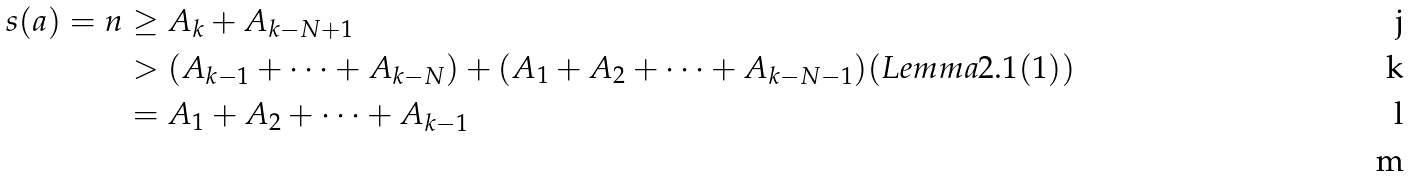Convert formula to latex. <formula><loc_0><loc_0><loc_500><loc_500>s ( a ) = n & \geq A _ { k } + A _ { k - N + 1 } \\ & > ( A _ { k - 1 } + \cdots + A _ { k - N } ) + ( A _ { 1 } + A _ { 2 } + \cdots + A _ { k - N - 1 } ) ( L e m m a 2 . 1 ( 1 ) ) \\ & = A _ { 1 } + A _ { 2 } + \cdots + A _ { k - 1 } \\</formula> 